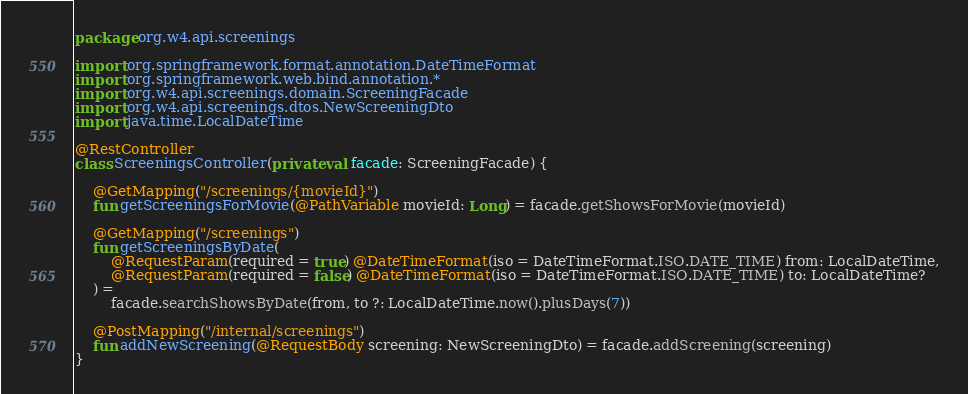Convert code to text. <code><loc_0><loc_0><loc_500><loc_500><_Kotlin_>package org.w4.api.screenings

import org.springframework.format.annotation.DateTimeFormat
import org.springframework.web.bind.annotation.*
import org.w4.api.screenings.domain.ScreeningFacade
import org.w4.api.screenings.dtos.NewScreeningDto
import java.time.LocalDateTime

@RestController
class ScreeningsController(private val facade: ScreeningFacade) {

    @GetMapping("/screenings/{movieId}")
    fun getScreeningsForMovie(@PathVariable movieId: Long) = facade.getShowsForMovie(movieId)

    @GetMapping("/screenings")
    fun getScreeningsByDate(
        @RequestParam(required = true) @DateTimeFormat(iso = DateTimeFormat.ISO.DATE_TIME) from: LocalDateTime,
        @RequestParam(required = false) @DateTimeFormat(iso = DateTimeFormat.ISO.DATE_TIME) to: LocalDateTime?
    ) =
        facade.searchShowsByDate(from, to ?: LocalDateTime.now().plusDays(7))

    @PostMapping("/internal/screenings")
    fun addNewScreening(@RequestBody screening: NewScreeningDto) = facade.addScreening(screening)
}</code> 